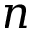Convert formula to latex. <formula><loc_0><loc_0><loc_500><loc_500>n</formula> 